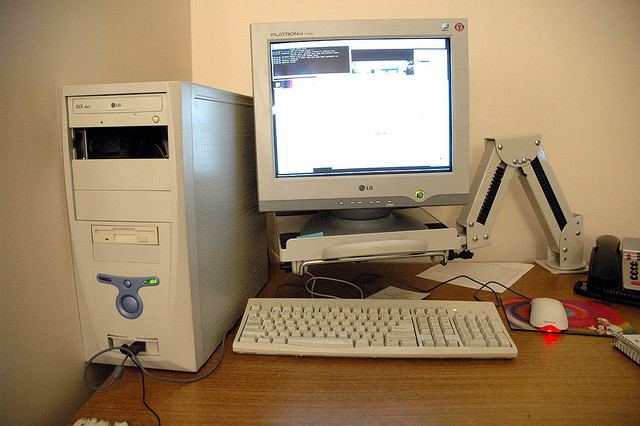<image>What brand of computer is this? I am not sure about the brand of the computer. It can be LG, e machines, Dell, IBM, or HP. What brand is the computer? I am not sure what brand the computer is. It could be LG or IBM. What brand of computer is this? I am not sure what brand of computer it is. It could be LG, eMachines, Dell, IBM, or HP. What brand is the computer? I don't know what brand the computer is. It can be LG or IBM. 